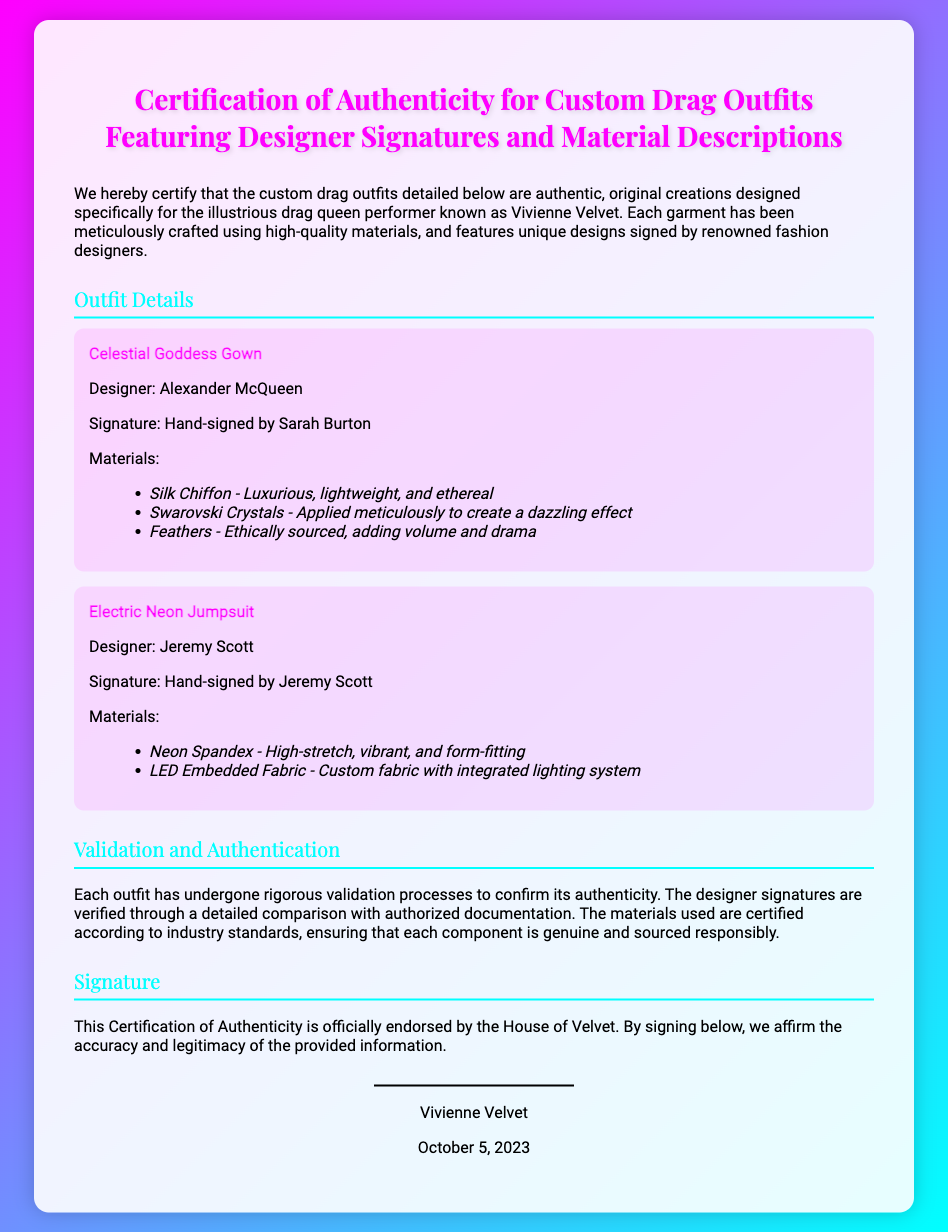What is the title of the document? The title is stated at the top of the document, which identifies the purpose of the certification.
Answer: Certification of Authenticity for Custom Drag Outfits Featuring Designer Signatures and Material Descriptions Who is the drag queen performer mentioned? The document explicitly mentions the drag queen performer for whom the outfits were designed.
Answer: Vivienne Velvet How many outfits are detailed in the document? The document lists two custom drag outfits with descriptions.
Answer: 2 Who designed the Celestial Goddess Gown? The designer's name is clearly stated in relation to the specific outfit.
Answer: Alexander McQueen What material is used in the Electric Neon Jumpsuit? The document provides a list of materials used in each outfit, one of which is Neon Spandex.
Answer: Neon Spandex What date was the declaration signed? The signing date is mentioned at the end of the document, indicating when it was officially endorsed.
Answer: October 5, 2023 What is mentioned about the validation process? The document states that each outfit underwent rigorous validation to confirm authenticity.
Answer: Rigorous validation processes Who affirms the accuracy of the information? The signature section names the person who officially endorses the document's contents.
Answer: Vivienne Velvet 